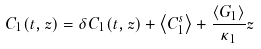Convert formula to latex. <formula><loc_0><loc_0><loc_500><loc_500>C _ { 1 } ( t , z ) = \delta C _ { 1 } ( t , z ) + \left < C _ { 1 } ^ { s } \right > + \frac { \left < G _ { 1 } \right > } { \kappa _ { 1 } } z</formula> 